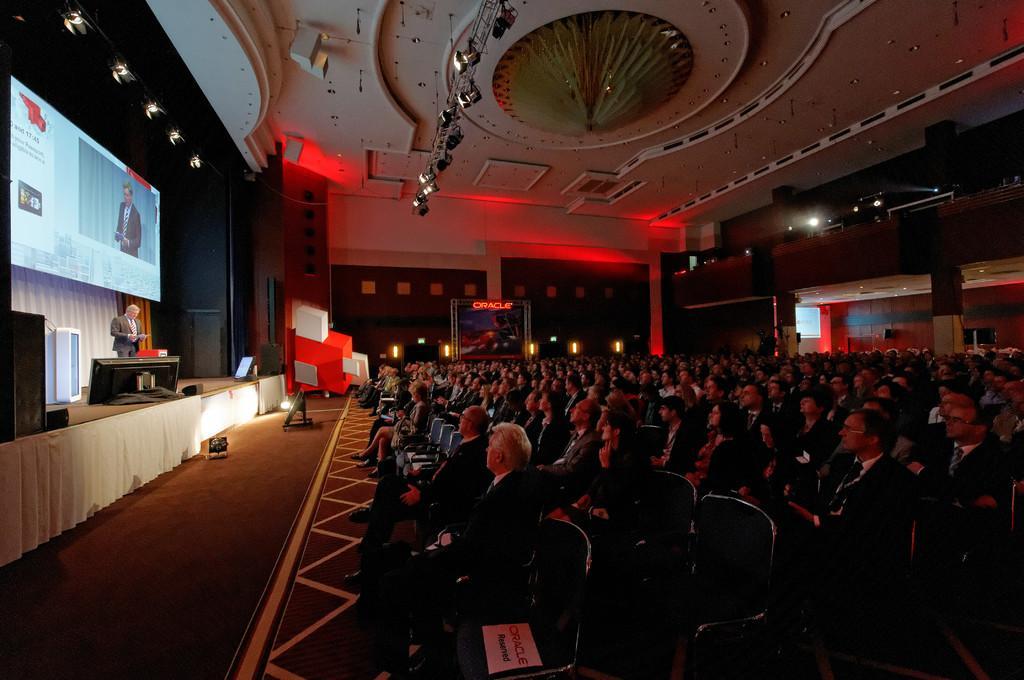How would you summarize this image in a sentence or two? This image is taken indoors. At the top of the image there is a ceiling with a chandelier and a few lights. On the left side of the image there are a few walls and there is a screen and curtains on the wall. A man is standing on the dais and there are a few things on the dais. On the right side of the image many people are sitting on the chairs. In the background there are a few walls, pillars and lamps and there is a board with a text on it. 